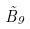Convert formula to latex. <formula><loc_0><loc_0><loc_500><loc_500>\tilde { B } _ { 9 }</formula> 